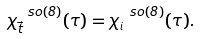Convert formula to latex. <formula><loc_0><loc_0><loc_500><loc_500>\chi ^ { \ s o ( 8 ) } _ { \vec { t } } ( \tau ) = \chi ^ { \ s o ( 8 ) } _ { ^ { i } } ( \tau ) .</formula> 